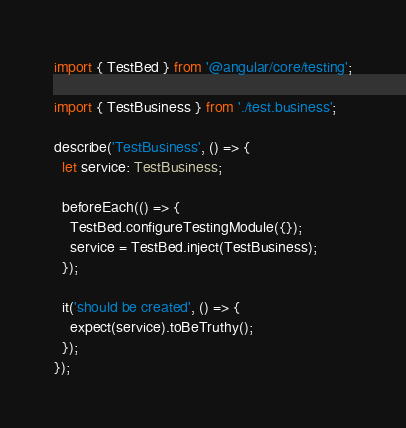Convert code to text. <code><loc_0><loc_0><loc_500><loc_500><_TypeScript_>import { TestBed } from '@angular/core/testing';

import { TestBusiness } from './test.business';

describe('TestBusiness', () => {
  let service: TestBusiness;

  beforeEach(() => {
    TestBed.configureTestingModule({});
    service = TestBed.inject(TestBusiness);
  });

  it('should be created', () => {
    expect(service).toBeTruthy();
  });
});
</code> 